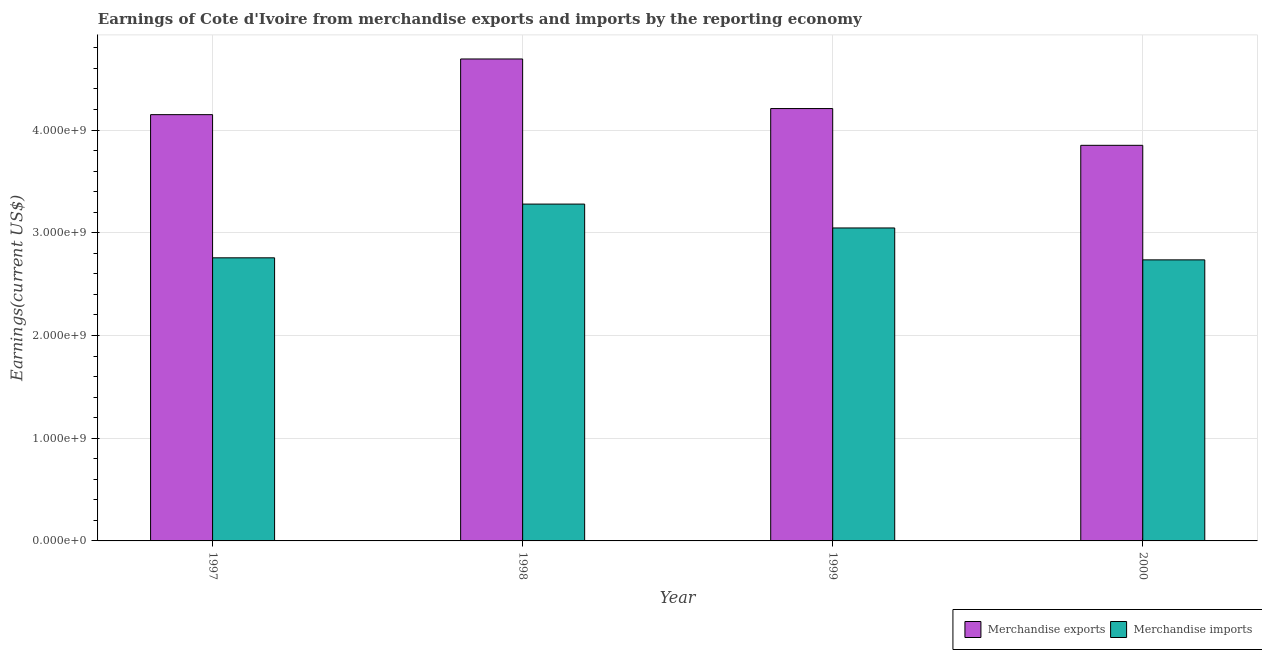Are the number of bars per tick equal to the number of legend labels?
Offer a terse response. Yes. Are the number of bars on each tick of the X-axis equal?
Your answer should be compact. Yes. How many bars are there on the 4th tick from the left?
Ensure brevity in your answer.  2. How many bars are there on the 1st tick from the right?
Your answer should be very brief. 2. In how many cases, is the number of bars for a given year not equal to the number of legend labels?
Keep it short and to the point. 0. What is the earnings from merchandise exports in 1998?
Your answer should be compact. 4.69e+09. Across all years, what is the maximum earnings from merchandise exports?
Your answer should be compact. 4.69e+09. Across all years, what is the minimum earnings from merchandise exports?
Ensure brevity in your answer.  3.85e+09. What is the total earnings from merchandise imports in the graph?
Give a very brief answer. 1.18e+1. What is the difference between the earnings from merchandise imports in 1997 and that in 2000?
Offer a terse response. 1.99e+07. What is the difference between the earnings from merchandise imports in 1997 and the earnings from merchandise exports in 1998?
Your answer should be very brief. -5.23e+08. What is the average earnings from merchandise imports per year?
Your answer should be compact. 2.95e+09. In the year 1999, what is the difference between the earnings from merchandise exports and earnings from merchandise imports?
Ensure brevity in your answer.  0. What is the ratio of the earnings from merchandise exports in 1997 to that in 1998?
Your answer should be very brief. 0.88. Is the earnings from merchandise imports in 1998 less than that in 1999?
Offer a very short reply. No. What is the difference between the highest and the second highest earnings from merchandise exports?
Offer a terse response. 4.83e+08. What is the difference between the highest and the lowest earnings from merchandise exports?
Make the answer very short. 8.41e+08. Is the sum of the earnings from merchandise exports in 1999 and 2000 greater than the maximum earnings from merchandise imports across all years?
Offer a terse response. Yes. What does the 2nd bar from the right in 1997 represents?
Keep it short and to the point. Merchandise exports. Are all the bars in the graph horizontal?
Offer a terse response. No. What is the difference between two consecutive major ticks on the Y-axis?
Offer a very short reply. 1.00e+09. How many legend labels are there?
Offer a terse response. 2. What is the title of the graph?
Provide a short and direct response. Earnings of Cote d'Ivoire from merchandise exports and imports by the reporting economy. What is the label or title of the Y-axis?
Your answer should be very brief. Earnings(current US$). What is the Earnings(current US$) of Merchandise exports in 1997?
Keep it short and to the point. 4.15e+09. What is the Earnings(current US$) in Merchandise imports in 1997?
Your answer should be very brief. 2.76e+09. What is the Earnings(current US$) of Merchandise exports in 1998?
Make the answer very short. 4.69e+09. What is the Earnings(current US$) of Merchandise imports in 1998?
Offer a terse response. 3.28e+09. What is the Earnings(current US$) in Merchandise exports in 1999?
Make the answer very short. 4.21e+09. What is the Earnings(current US$) in Merchandise imports in 1999?
Your response must be concise. 3.05e+09. What is the Earnings(current US$) of Merchandise exports in 2000?
Keep it short and to the point. 3.85e+09. What is the Earnings(current US$) of Merchandise imports in 2000?
Your response must be concise. 2.74e+09. Across all years, what is the maximum Earnings(current US$) of Merchandise exports?
Your answer should be compact. 4.69e+09. Across all years, what is the maximum Earnings(current US$) in Merchandise imports?
Make the answer very short. 3.28e+09. Across all years, what is the minimum Earnings(current US$) in Merchandise exports?
Offer a terse response. 3.85e+09. Across all years, what is the minimum Earnings(current US$) of Merchandise imports?
Offer a very short reply. 2.74e+09. What is the total Earnings(current US$) of Merchandise exports in the graph?
Your answer should be very brief. 1.69e+1. What is the total Earnings(current US$) in Merchandise imports in the graph?
Offer a very short reply. 1.18e+1. What is the difference between the Earnings(current US$) of Merchandise exports in 1997 and that in 1998?
Your answer should be compact. -5.42e+08. What is the difference between the Earnings(current US$) of Merchandise imports in 1997 and that in 1998?
Provide a succinct answer. -5.23e+08. What is the difference between the Earnings(current US$) in Merchandise exports in 1997 and that in 1999?
Your answer should be very brief. -5.94e+07. What is the difference between the Earnings(current US$) of Merchandise imports in 1997 and that in 1999?
Your response must be concise. -2.91e+08. What is the difference between the Earnings(current US$) of Merchandise exports in 1997 and that in 2000?
Your answer should be very brief. 2.99e+08. What is the difference between the Earnings(current US$) in Merchandise imports in 1997 and that in 2000?
Your response must be concise. 1.99e+07. What is the difference between the Earnings(current US$) in Merchandise exports in 1998 and that in 1999?
Keep it short and to the point. 4.83e+08. What is the difference between the Earnings(current US$) of Merchandise imports in 1998 and that in 1999?
Give a very brief answer. 2.33e+08. What is the difference between the Earnings(current US$) of Merchandise exports in 1998 and that in 2000?
Your response must be concise. 8.41e+08. What is the difference between the Earnings(current US$) of Merchandise imports in 1998 and that in 2000?
Offer a very short reply. 5.43e+08. What is the difference between the Earnings(current US$) of Merchandise exports in 1999 and that in 2000?
Keep it short and to the point. 3.58e+08. What is the difference between the Earnings(current US$) in Merchandise imports in 1999 and that in 2000?
Offer a very short reply. 3.11e+08. What is the difference between the Earnings(current US$) in Merchandise exports in 1997 and the Earnings(current US$) in Merchandise imports in 1998?
Keep it short and to the point. 8.71e+08. What is the difference between the Earnings(current US$) of Merchandise exports in 1997 and the Earnings(current US$) of Merchandise imports in 1999?
Offer a very short reply. 1.10e+09. What is the difference between the Earnings(current US$) in Merchandise exports in 1997 and the Earnings(current US$) in Merchandise imports in 2000?
Your response must be concise. 1.41e+09. What is the difference between the Earnings(current US$) in Merchandise exports in 1998 and the Earnings(current US$) in Merchandise imports in 1999?
Your answer should be very brief. 1.65e+09. What is the difference between the Earnings(current US$) of Merchandise exports in 1998 and the Earnings(current US$) of Merchandise imports in 2000?
Offer a very short reply. 1.96e+09. What is the difference between the Earnings(current US$) of Merchandise exports in 1999 and the Earnings(current US$) of Merchandise imports in 2000?
Your answer should be very brief. 1.47e+09. What is the average Earnings(current US$) in Merchandise exports per year?
Offer a very short reply. 4.23e+09. What is the average Earnings(current US$) of Merchandise imports per year?
Offer a terse response. 2.95e+09. In the year 1997, what is the difference between the Earnings(current US$) in Merchandise exports and Earnings(current US$) in Merchandise imports?
Your response must be concise. 1.39e+09. In the year 1998, what is the difference between the Earnings(current US$) of Merchandise exports and Earnings(current US$) of Merchandise imports?
Give a very brief answer. 1.41e+09. In the year 1999, what is the difference between the Earnings(current US$) of Merchandise exports and Earnings(current US$) of Merchandise imports?
Ensure brevity in your answer.  1.16e+09. In the year 2000, what is the difference between the Earnings(current US$) in Merchandise exports and Earnings(current US$) in Merchandise imports?
Provide a short and direct response. 1.12e+09. What is the ratio of the Earnings(current US$) in Merchandise exports in 1997 to that in 1998?
Offer a very short reply. 0.88. What is the ratio of the Earnings(current US$) of Merchandise imports in 1997 to that in 1998?
Keep it short and to the point. 0.84. What is the ratio of the Earnings(current US$) in Merchandise exports in 1997 to that in 1999?
Your response must be concise. 0.99. What is the ratio of the Earnings(current US$) in Merchandise imports in 1997 to that in 1999?
Your response must be concise. 0.9. What is the ratio of the Earnings(current US$) in Merchandise exports in 1997 to that in 2000?
Give a very brief answer. 1.08. What is the ratio of the Earnings(current US$) in Merchandise imports in 1997 to that in 2000?
Ensure brevity in your answer.  1.01. What is the ratio of the Earnings(current US$) of Merchandise exports in 1998 to that in 1999?
Give a very brief answer. 1.11. What is the ratio of the Earnings(current US$) of Merchandise imports in 1998 to that in 1999?
Offer a very short reply. 1.08. What is the ratio of the Earnings(current US$) in Merchandise exports in 1998 to that in 2000?
Keep it short and to the point. 1.22. What is the ratio of the Earnings(current US$) of Merchandise imports in 1998 to that in 2000?
Keep it short and to the point. 1.2. What is the ratio of the Earnings(current US$) in Merchandise exports in 1999 to that in 2000?
Make the answer very short. 1.09. What is the ratio of the Earnings(current US$) in Merchandise imports in 1999 to that in 2000?
Keep it short and to the point. 1.11. What is the difference between the highest and the second highest Earnings(current US$) of Merchandise exports?
Provide a short and direct response. 4.83e+08. What is the difference between the highest and the second highest Earnings(current US$) in Merchandise imports?
Provide a succinct answer. 2.33e+08. What is the difference between the highest and the lowest Earnings(current US$) in Merchandise exports?
Provide a succinct answer. 8.41e+08. What is the difference between the highest and the lowest Earnings(current US$) in Merchandise imports?
Give a very brief answer. 5.43e+08. 